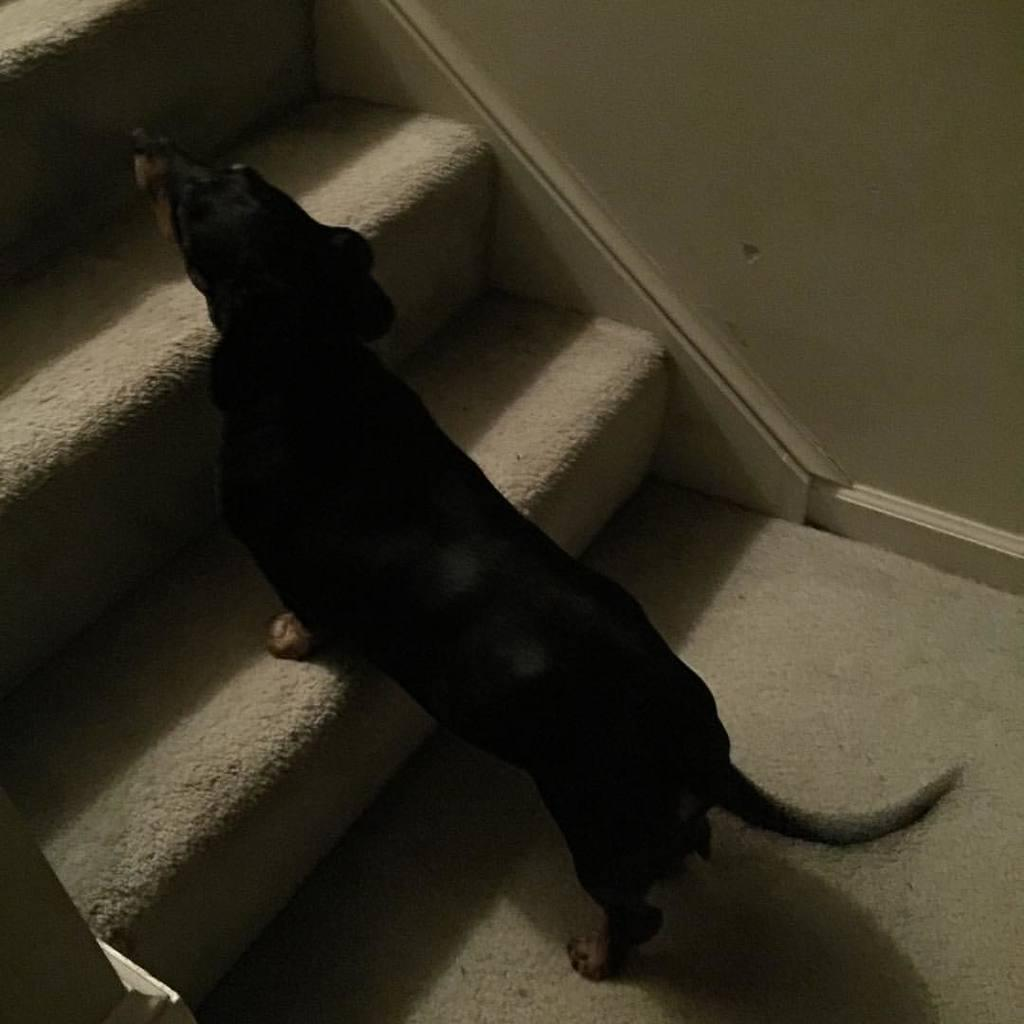What type of animal is in the image? There is a black dog in the image. Where is the dog located in the image? The dog is standing on steps. What type of vessel is the dog using to climb the steps in the image? There is no vessel present in the image; the dog is standing on the steps without any assistance. 